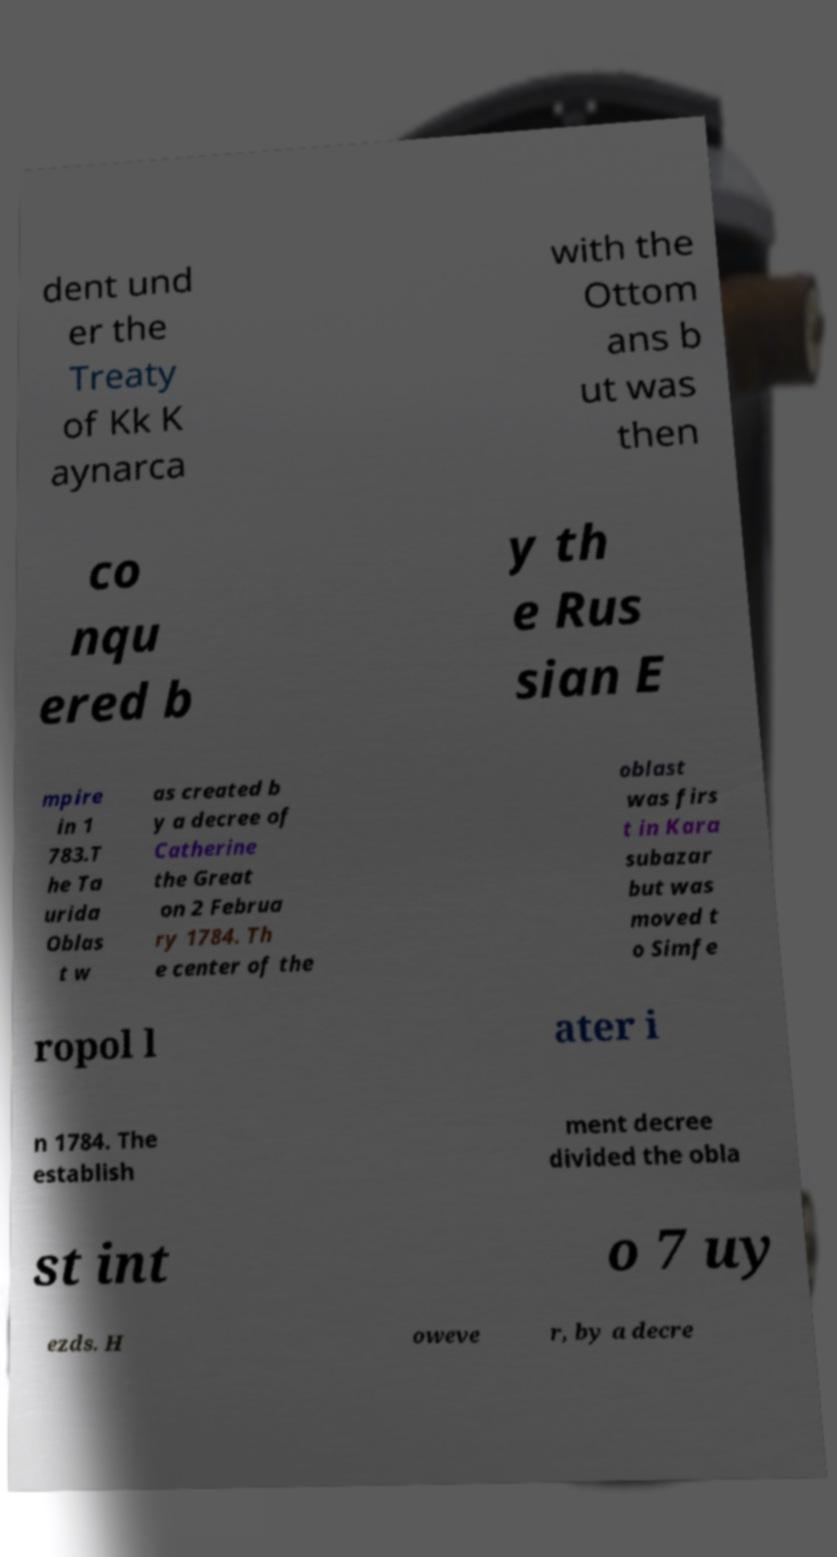I need the written content from this picture converted into text. Can you do that? dent und er the Treaty of Kk K aynarca with the Ottom ans b ut was then co nqu ered b y th e Rus sian E mpire in 1 783.T he Ta urida Oblas t w as created b y a decree of Catherine the Great on 2 Februa ry 1784. Th e center of the oblast was firs t in Kara subazar but was moved t o Simfe ropol l ater i n 1784. The establish ment decree divided the obla st int o 7 uy ezds. H oweve r, by a decre 